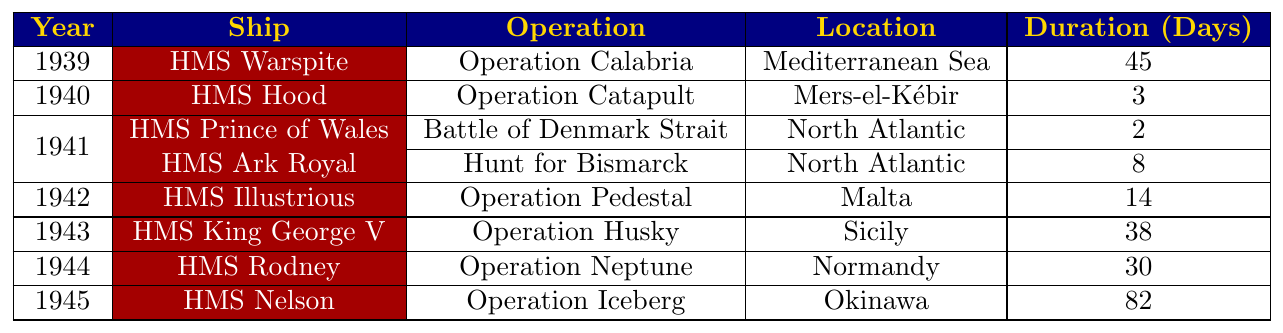What ship participated in the longest deployment during World War II? By examining the "Duration (Days)" column, we find that HMS Nelson had the longest deployment at 82 days during Operation Iceberg.
Answer: HMS Nelson In which year did HMS Hood conduct its operation? The table shows that HMS Hood performed its operation in 1940 as indicated in the "Year" column next to the ship's name.
Answer: 1940 Which location was associated with HMS Ark Royal's deployment? Looking at the table, the "Location" column reveals that HMS Ark Royal was deployed in the North Atlantic during its operation.
Answer: North Atlantic What was the total duration of deployments for HMS King George V and HMS Illustrious combined? HMS King George V's deployment lasted 38 days and HMS Illustrious's lasted 14 days. Adding these gives a total of 38 + 14 = 52 days.
Answer: 52 days Did any ship participate in operations in the Mediterranean Sea? Yes, HMS Warspite was deployed in the Mediterranean Sea as indicated in the "Location" column.
Answer: Yes Which ship had the shortest deployment duration and how long was it? The table indicates that HMS Hood had the shortest deployment at 3 days during Operation Catapult.
Answer: HMS Hood, 3 days How many ships were deployed in the year 1941? The table lists two ships, HMS Prince of Wales and HMS Ark Royal, for the year 1941, which can be counted from the entries under that year.
Answer: 2 ships Which operation lasted the least duration, and which ship was involved? The operation that lasted the least duration is Operation Catapult with HMS Hood, lasting only 3 days as seen in the "Duration (Days)" column.
Answer: Operation Catapult, HMS Hood Calculate the average duration of deployments for ships that were involved in operations in 1944 and 1945. For 1944, HMS Rodney's deployment lasted 30 days, and for 1945, HMS Nelson's deployment lasted 82 days. To find the average, we sum these (30 + 82 = 112) and divide by 2, yielding an average of 56 days.
Answer: 56 days Which operation in 1942 had the longest duration and how long was it? The table shows that Operation Pedestal involving HMS Illustrious lasted 14 days, indicating it was the longest operation in 1942.
Answer: Operation Pedestal, 14 days 